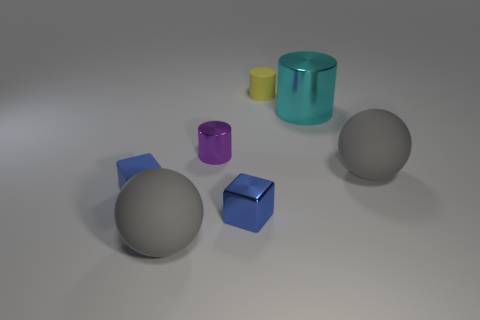Is there anything in the image that indicates size or scale? Without real-world objects for reference, it's challenging to determine the exact scale. However, the inconsistent sizes of the various objects relative to one another suggest they might represent a miniature collection or a set of objects without a uniform scale. 